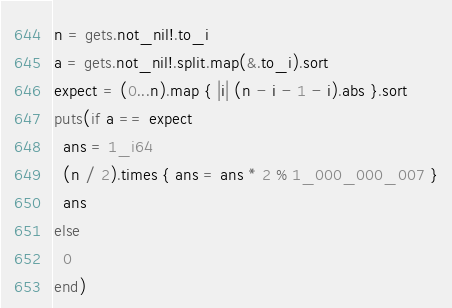<code> <loc_0><loc_0><loc_500><loc_500><_Crystal_>n = gets.not_nil!.to_i
a = gets.not_nil!.split.map(&.to_i).sort
expect = (0...n).map { |i| (n - i - 1 - i).abs }.sort
puts(if a == expect
  ans = 1_i64
  (n / 2).times { ans = ans * 2 % 1_000_000_007 }
  ans
else
  0
end)
</code> 